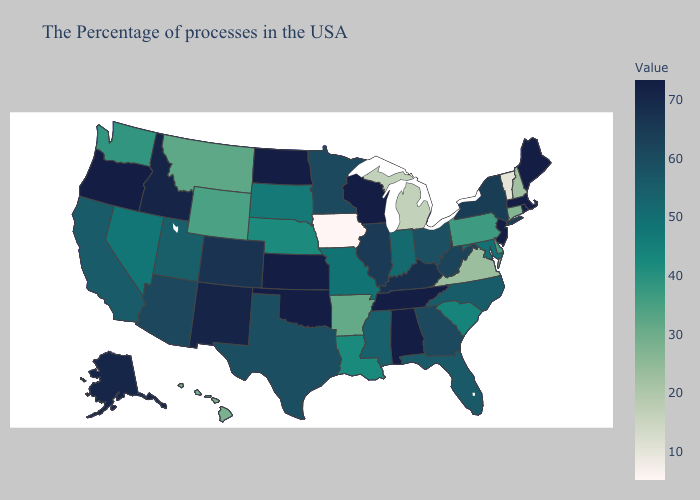Does Iowa have the lowest value in the USA?
Keep it brief. Yes. Does Pennsylvania have the lowest value in the Northeast?
Keep it brief. No. Among the states that border Indiana , which have the lowest value?
Concise answer only. Michigan. Is the legend a continuous bar?
Be succinct. Yes. Does Florida have a lower value than Connecticut?
Be succinct. No. Is the legend a continuous bar?
Answer briefly. Yes. 